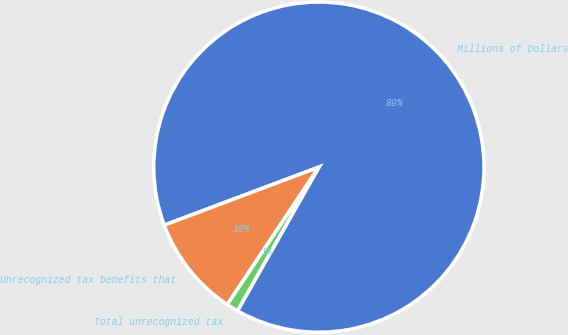Convert chart. <chart><loc_0><loc_0><loc_500><loc_500><pie_chart><fcel>Millions of Dollars<fcel>Unrecognized tax benefits that<fcel>Total unrecognized tax<nl><fcel>88.92%<fcel>9.93%<fcel>1.15%<nl></chart> 